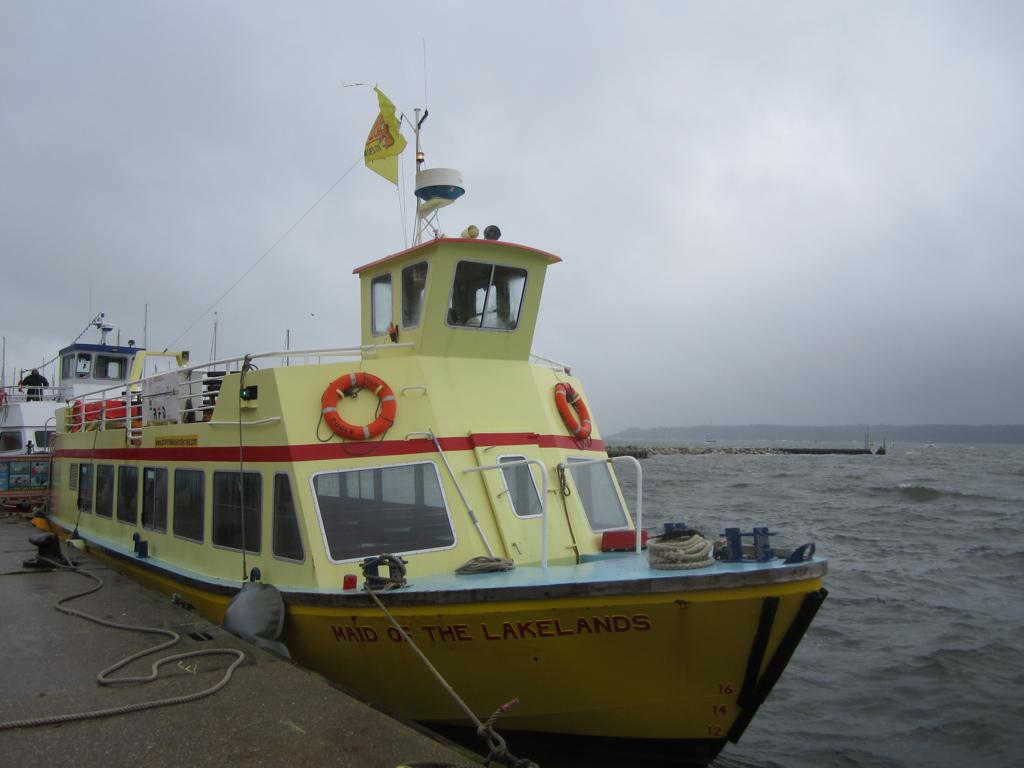What is in the water in the image? There is a boat in the water in the image. What can be seen flying in the image? There is a flag in the image. What is present for tying or securing in the image? There is a rope in the image. What type of natural landform is visible in the image? There is a mountain visible in the image. What is the condition of the sky in the image? The sky is cloudy in the image. What feature allows for visibility from inside the boat? There are windows on the boat. Can you see a quill being used to write on the boat in the image? There is no quill or writing activity visible in the image. What type of branch can be seen hanging over the boat in the image? There is no branch present in the image; it features a boat in the water with a mountain and cloudy sky in the background. 